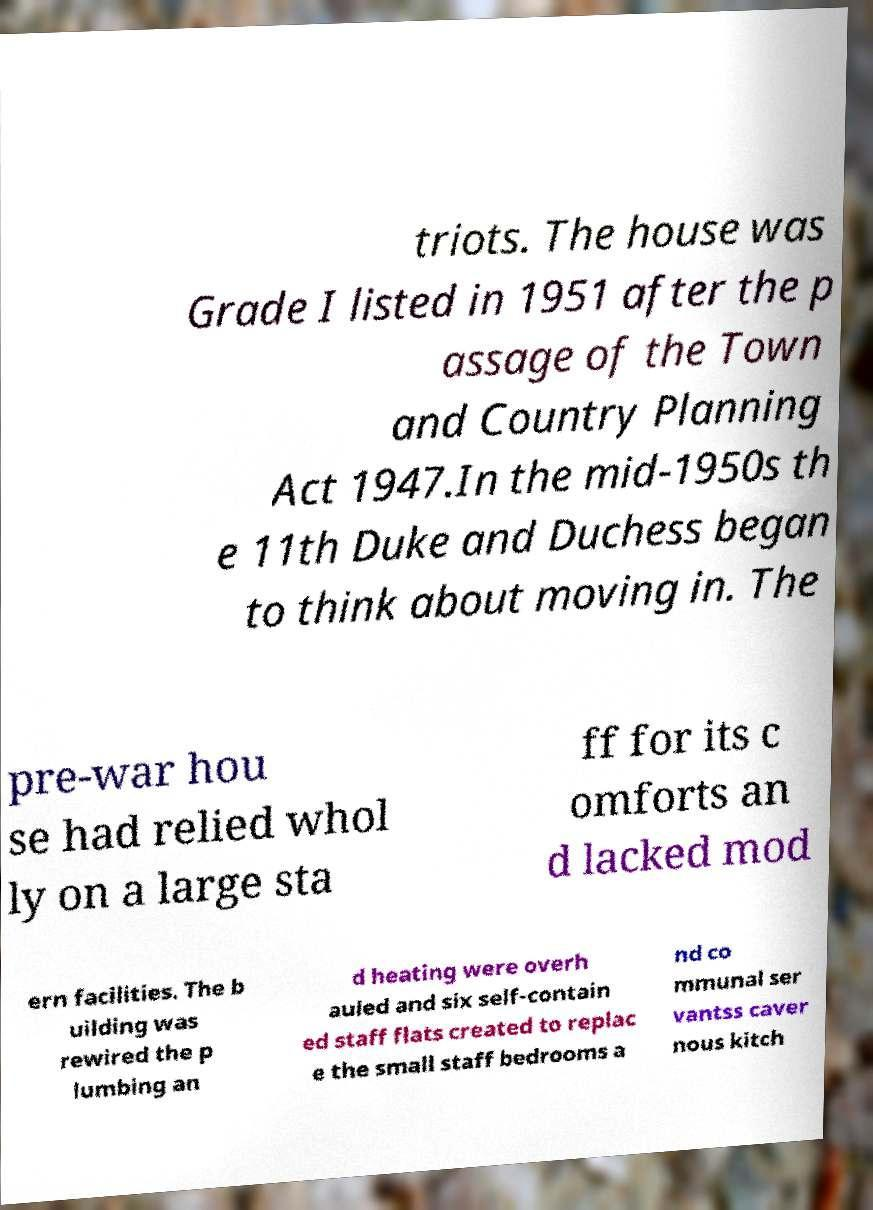There's text embedded in this image that I need extracted. Can you transcribe it verbatim? triots. The house was Grade I listed in 1951 after the p assage of the Town and Country Planning Act 1947.In the mid-1950s th e 11th Duke and Duchess began to think about moving in. The pre-war hou se had relied whol ly on a large sta ff for its c omforts an d lacked mod ern facilities. The b uilding was rewired the p lumbing an d heating were overh auled and six self-contain ed staff flats created to replac e the small staff bedrooms a nd co mmunal ser vantss caver nous kitch 